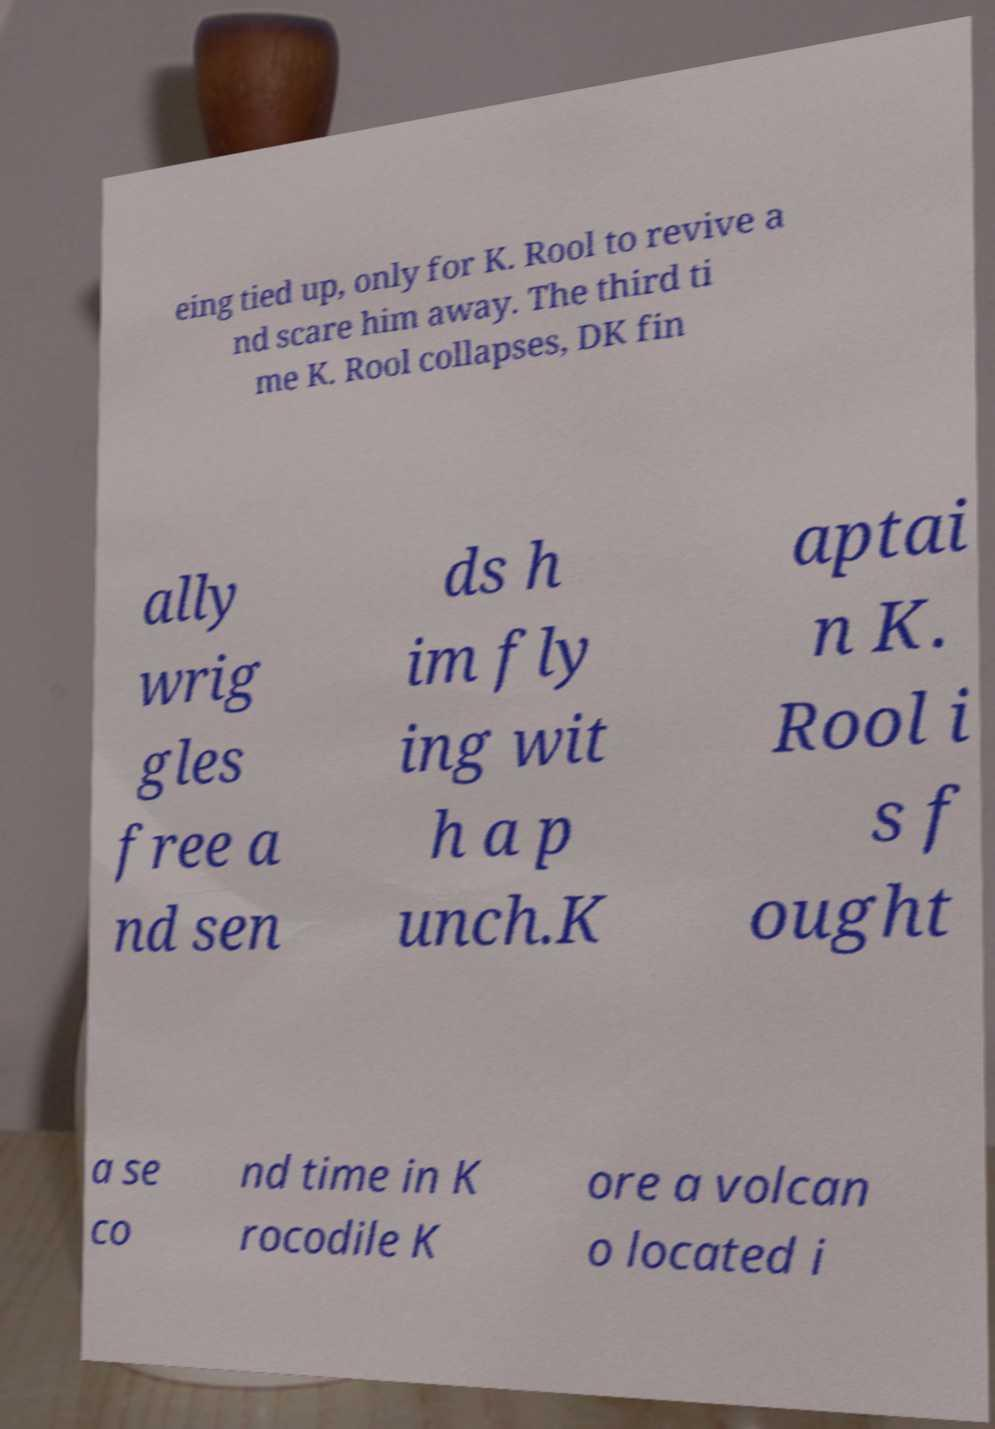Could you extract and type out the text from this image? eing tied up, only for K. Rool to revive a nd scare him away. The third ti me K. Rool collapses, DK fin ally wrig gles free a nd sen ds h im fly ing wit h a p unch.K aptai n K. Rool i s f ought a se co nd time in K rocodile K ore a volcan o located i 